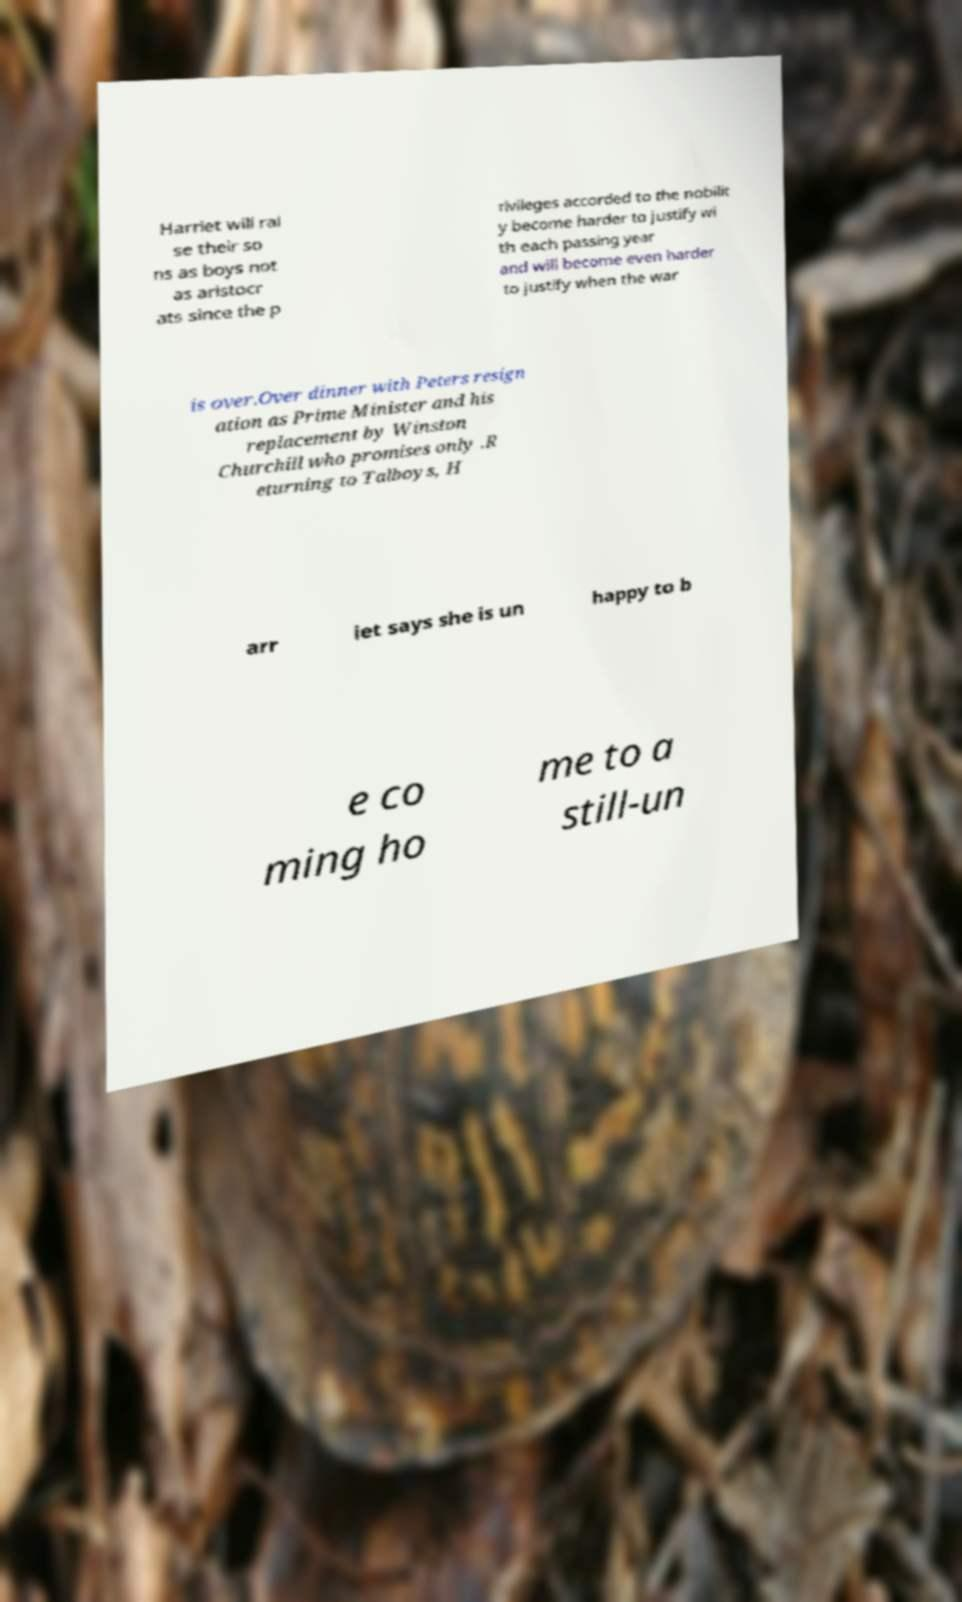Could you extract and type out the text from this image? Harriet will rai se their so ns as boys not as aristocr ats since the p rivileges accorded to the nobilit y become harder to justify wi th each passing year and will become even harder to justify when the war is over.Over dinner with Peters resign ation as Prime Minister and his replacement by Winston Churchill who promises only .R eturning to Talboys, H arr iet says she is un happy to b e co ming ho me to a still-un 